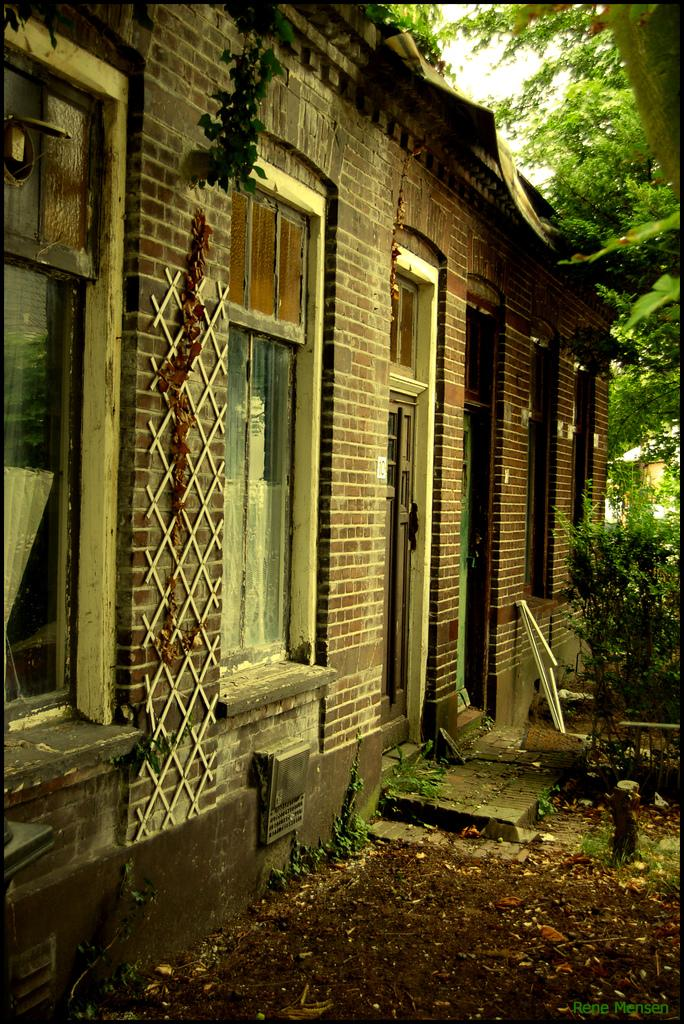What type of structure is visible in the image? There is a building in the image. What feature can be seen on the building? The building has windows. What type of vegetation is on the right side of the image? There are trees on the right side of the image. What is present on the ground in the image? Dry leaves are present on the ground. What is the condition of the sky in the image? The sky is cloudy in the image. Can you see any celery being crushed underfoot in the image? There is no celery or any indication of crushing in the image. 